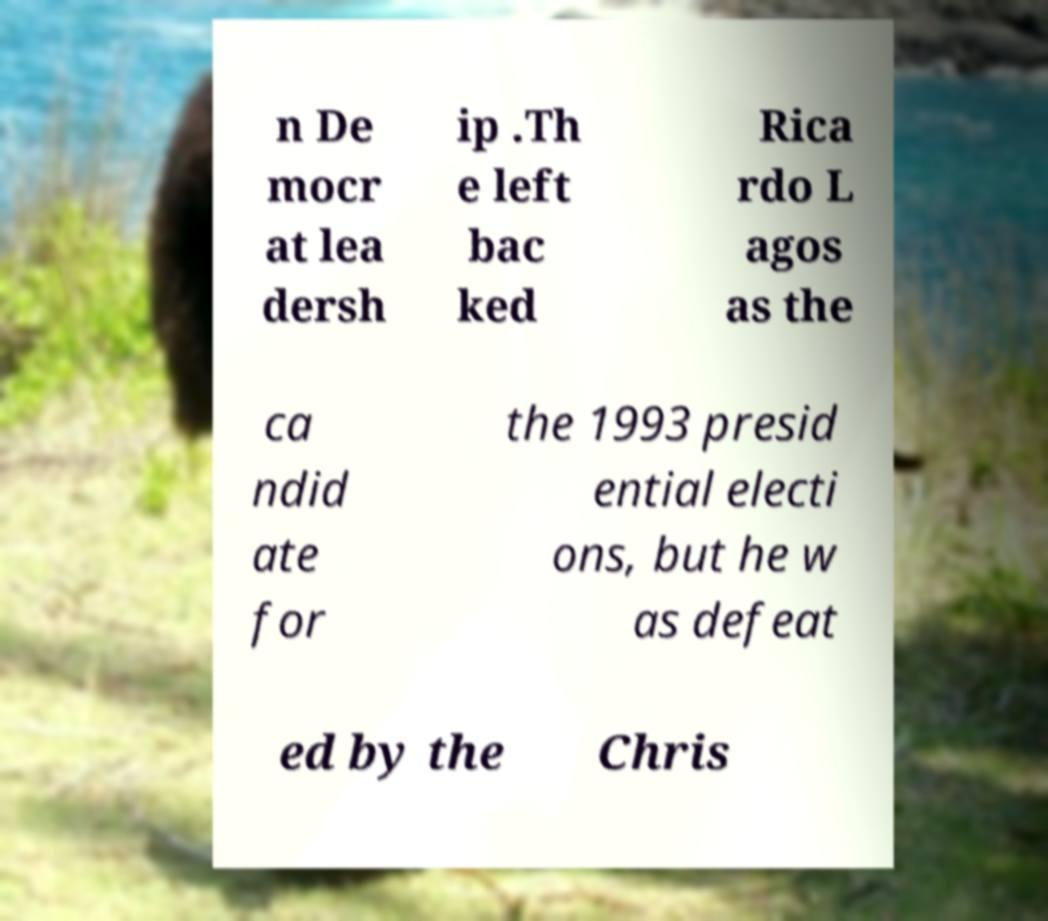For documentation purposes, I need the text within this image transcribed. Could you provide that? n De mocr at lea dersh ip .Th e left bac ked Rica rdo L agos as the ca ndid ate for the 1993 presid ential electi ons, but he w as defeat ed by the Chris 